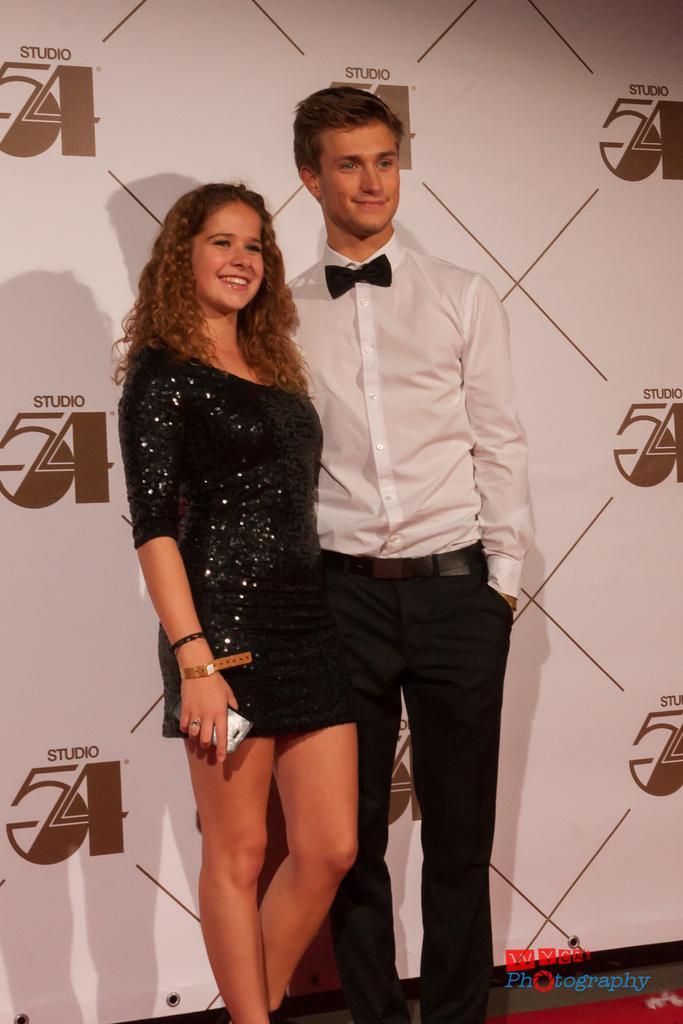Describe this image in one or two sentences. There are two persons standing on the stage and we can see a poster in the background. 